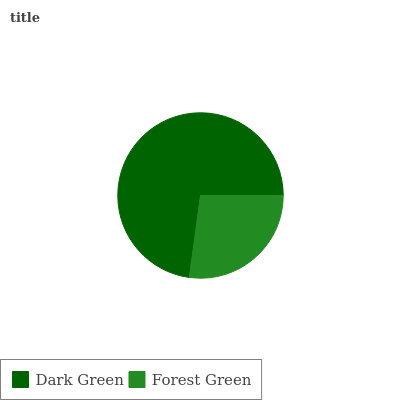Is Forest Green the minimum?
Answer yes or no. Yes. Is Dark Green the maximum?
Answer yes or no. Yes. Is Forest Green the maximum?
Answer yes or no. No. Is Dark Green greater than Forest Green?
Answer yes or no. Yes. Is Forest Green less than Dark Green?
Answer yes or no. Yes. Is Forest Green greater than Dark Green?
Answer yes or no. No. Is Dark Green less than Forest Green?
Answer yes or no. No. Is Dark Green the high median?
Answer yes or no. Yes. Is Forest Green the low median?
Answer yes or no. Yes. Is Forest Green the high median?
Answer yes or no. No. Is Dark Green the low median?
Answer yes or no. No. 